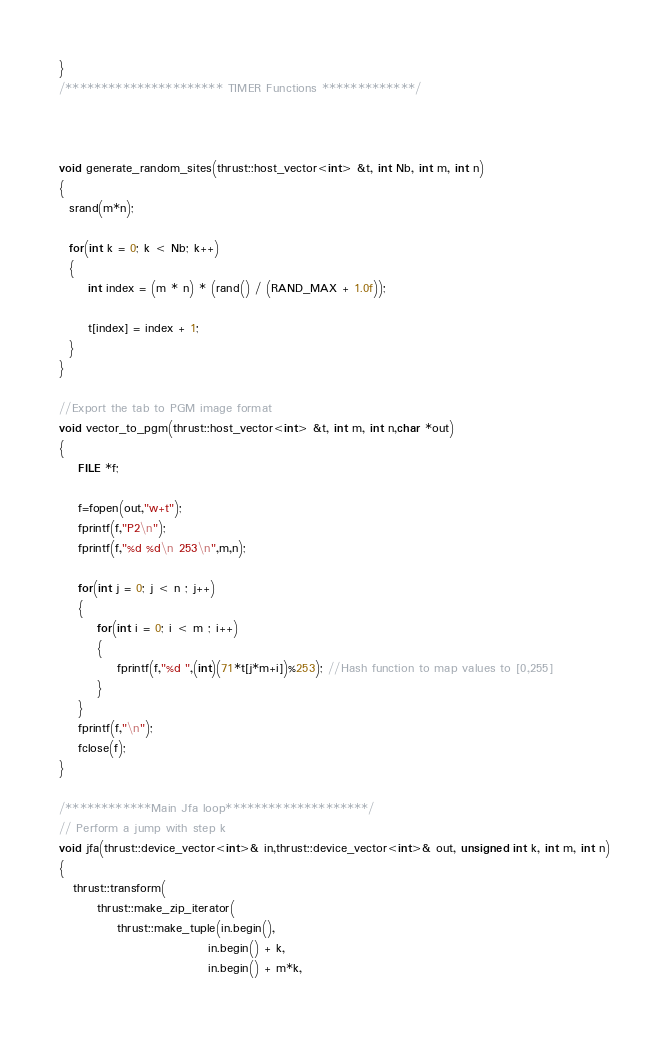<code> <loc_0><loc_0><loc_500><loc_500><_Cuda_>}
/********************** TIMER Functions *************/



void generate_random_sites(thrust::host_vector<int> &t, int Nb, int m, int n)
{
  srand(m*n);

  for(int k = 0; k < Nb; k++)
  {
      int index = (m * n) * (rand() / (RAND_MAX + 1.0f));

      t[index] = index + 1;
  }
}

//Export the tab to PGM image format
void vector_to_pgm(thrust::host_vector<int> &t, int m, int n,char *out)
{
    FILE *f;

    f=fopen(out,"w+t");
    fprintf(f,"P2\n");
    fprintf(f,"%d %d\n 253\n",m,n);

    for(int j = 0; j < n ; j++)
    {
        for(int i = 0; i < m ; i++)
        {
            fprintf(f,"%d ",(int)(71*t[j*m+i])%253); //Hash function to map values to [0,255]
        }
    }
    fprintf(f,"\n");
    fclose(f);
}

/************Main Jfa loop********************/
// Perform a jump with step k
void jfa(thrust::device_vector<int>& in,thrust::device_vector<int>& out, unsigned int k, int m, int n)
{
   thrust::transform(
        thrust::make_zip_iterator(
            thrust::make_tuple(in.begin(), 
                               in.begin() + k, 
                               in.begin() + m*k, </code> 